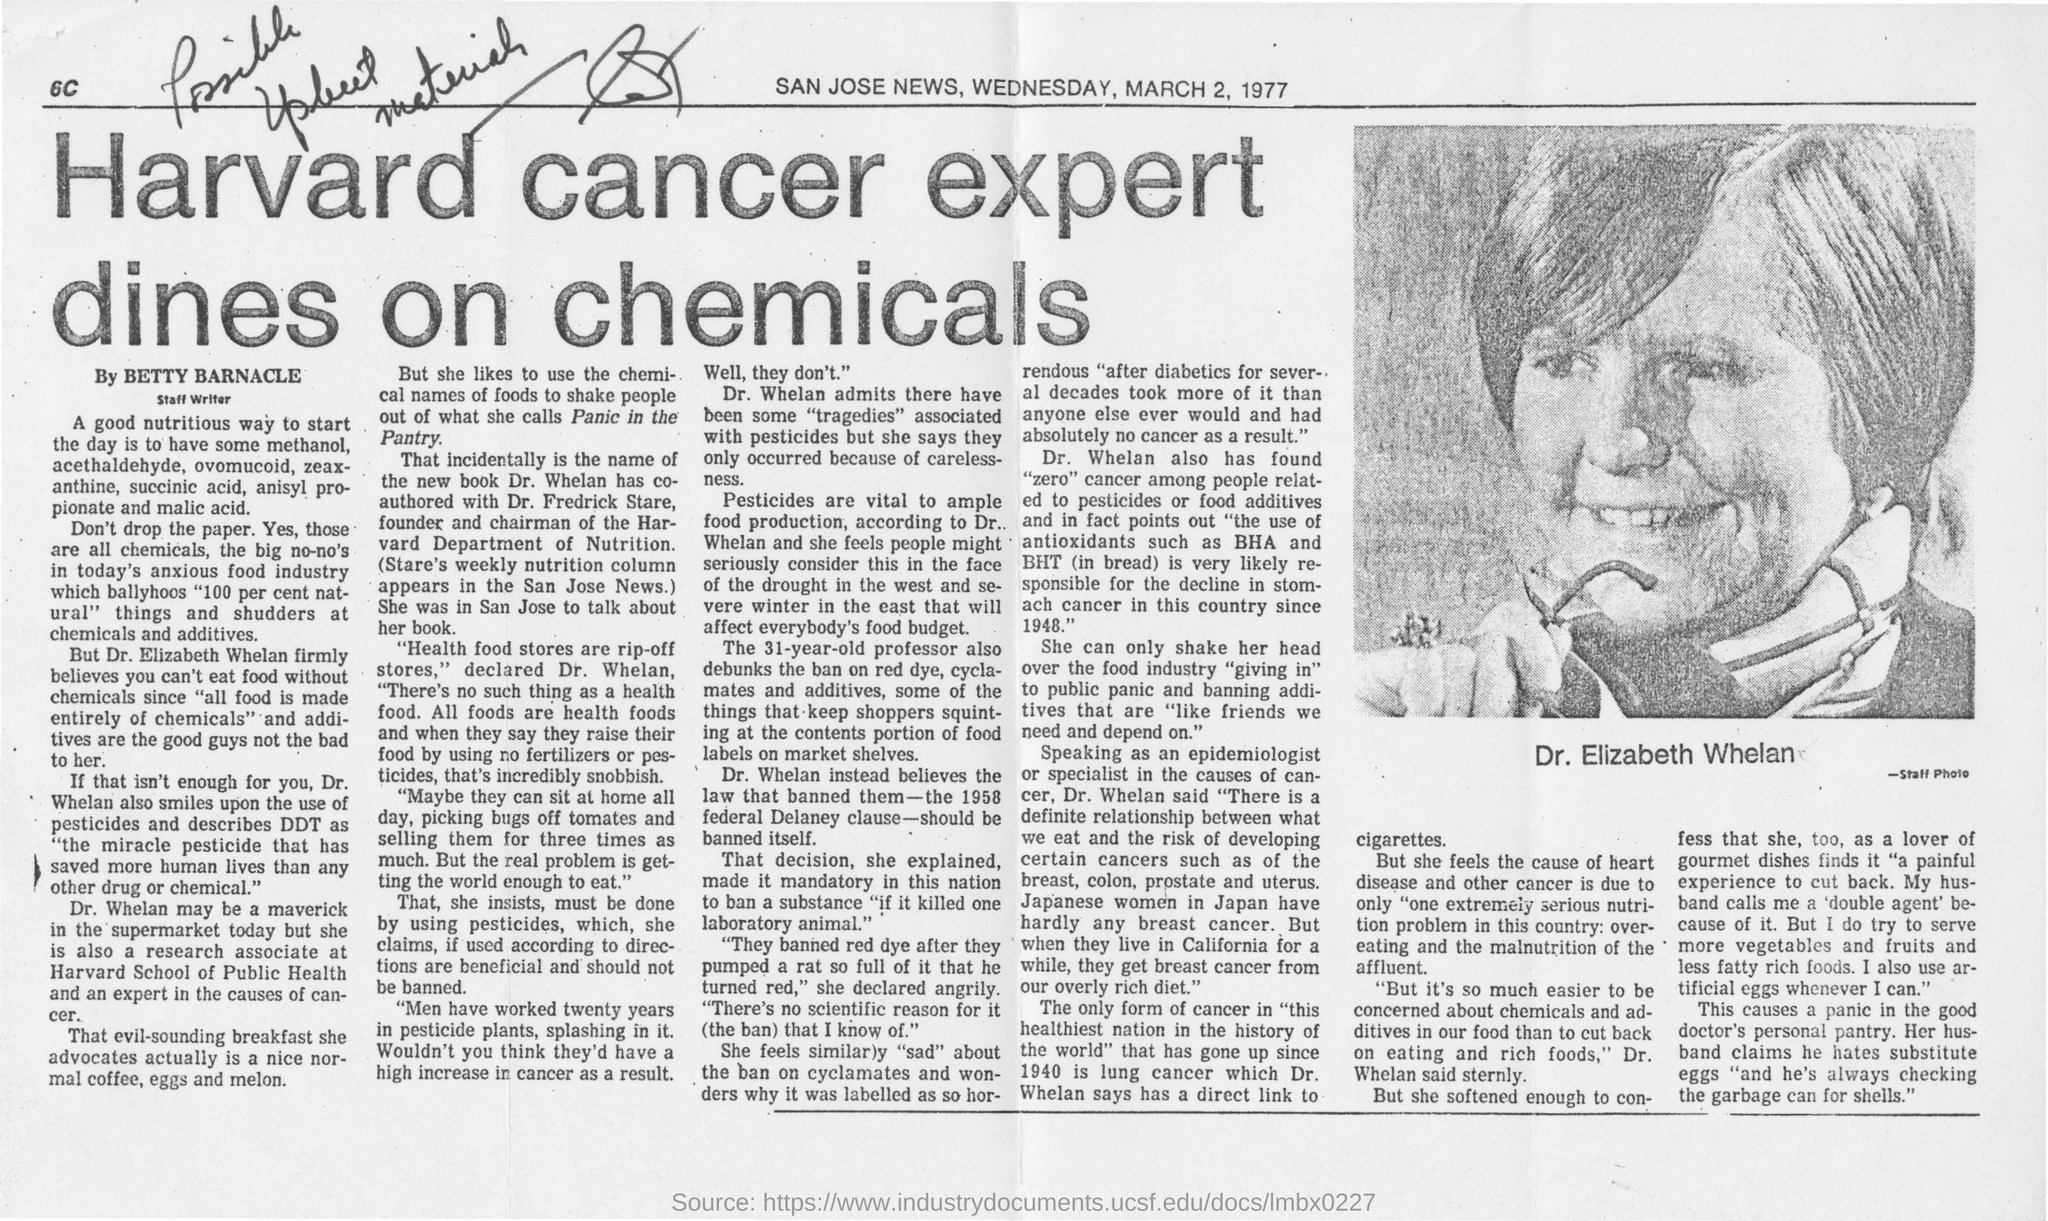Who's picture is shown in the newspaper?
Your answer should be very brief. DR. ELIZABETH WHELAN. What is the name of the newspaper?
Ensure brevity in your answer.  SAN JOSE NEWS. What is the date mentioned in the newspaper?
Provide a succinct answer. MARCH 2, 1977. What is the head line of the news?
Offer a terse response. Harvard cancer expert dines on chemicals. Who is the Staff Writer?
Keep it short and to the point. BETTY BARNACLE. What is vital to ample food production according to Dr. Whelan?
Provide a short and direct response. Pesticides. 